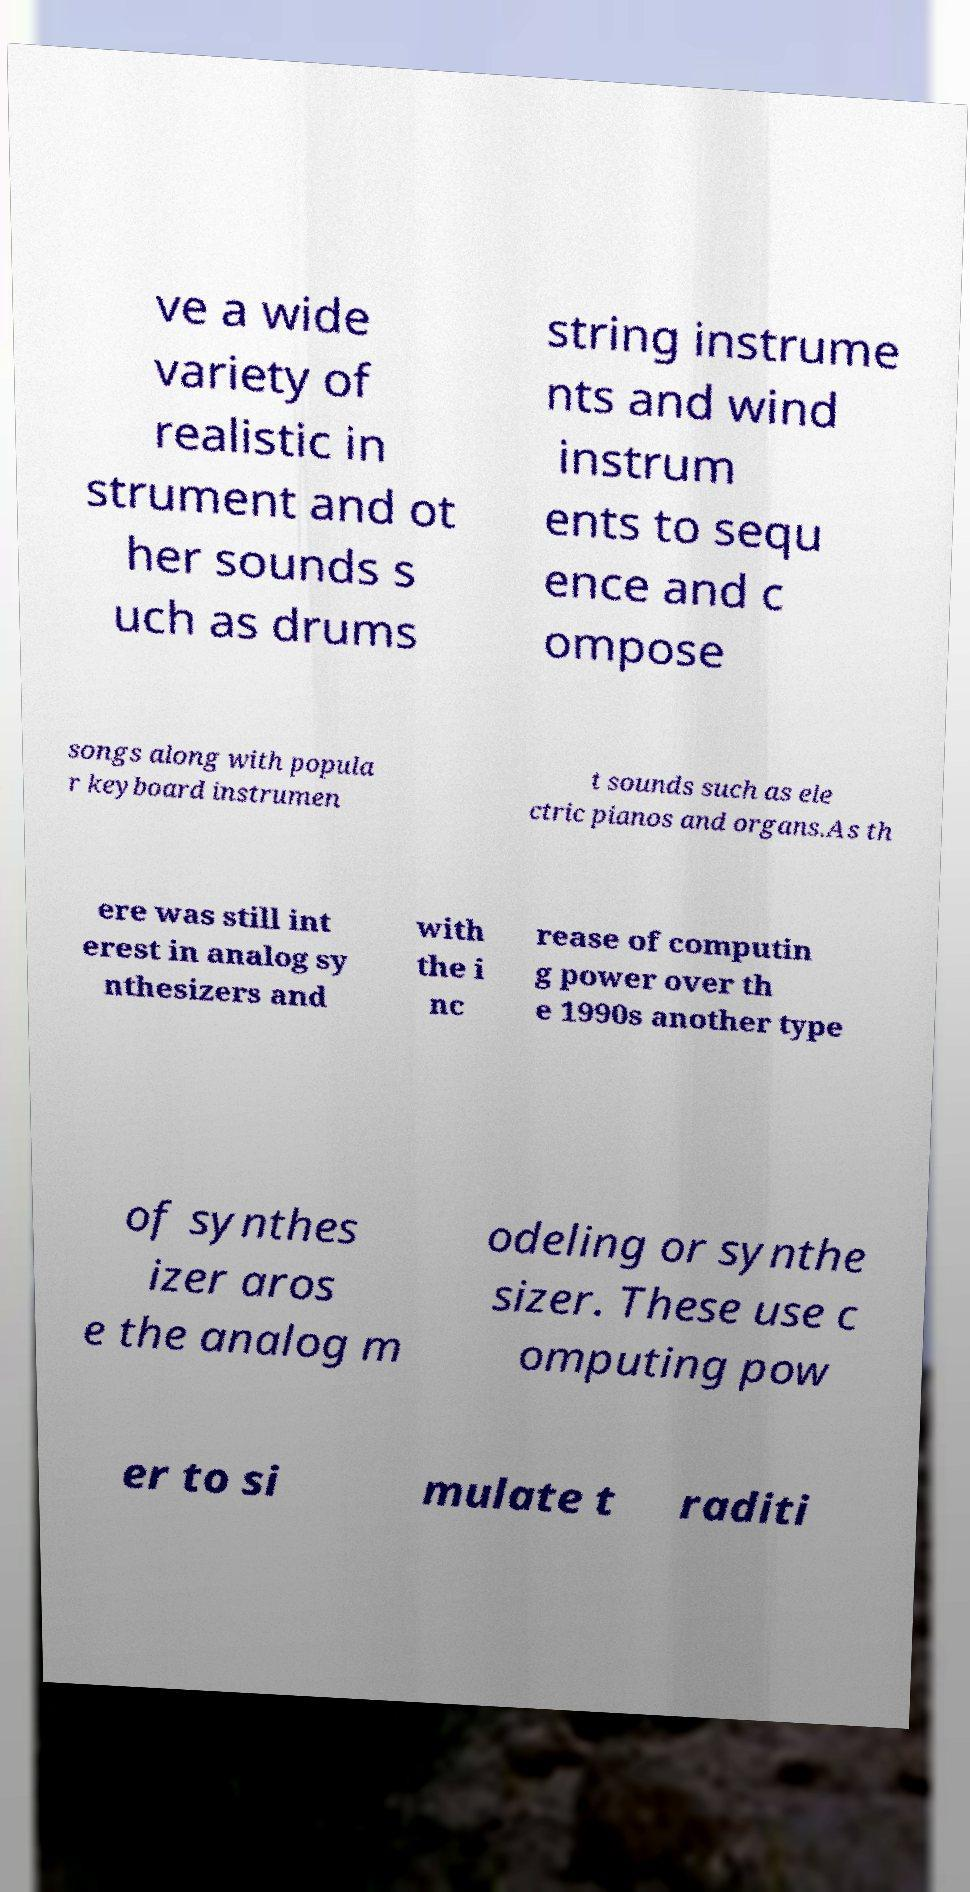Please read and relay the text visible in this image. What does it say? ve a wide variety of realistic in strument and ot her sounds s uch as drums string instrume nts and wind instrum ents to sequ ence and c ompose songs along with popula r keyboard instrumen t sounds such as ele ctric pianos and organs.As th ere was still int erest in analog sy nthesizers and with the i nc rease of computin g power over th e 1990s another type of synthes izer aros e the analog m odeling or synthe sizer. These use c omputing pow er to si mulate t raditi 